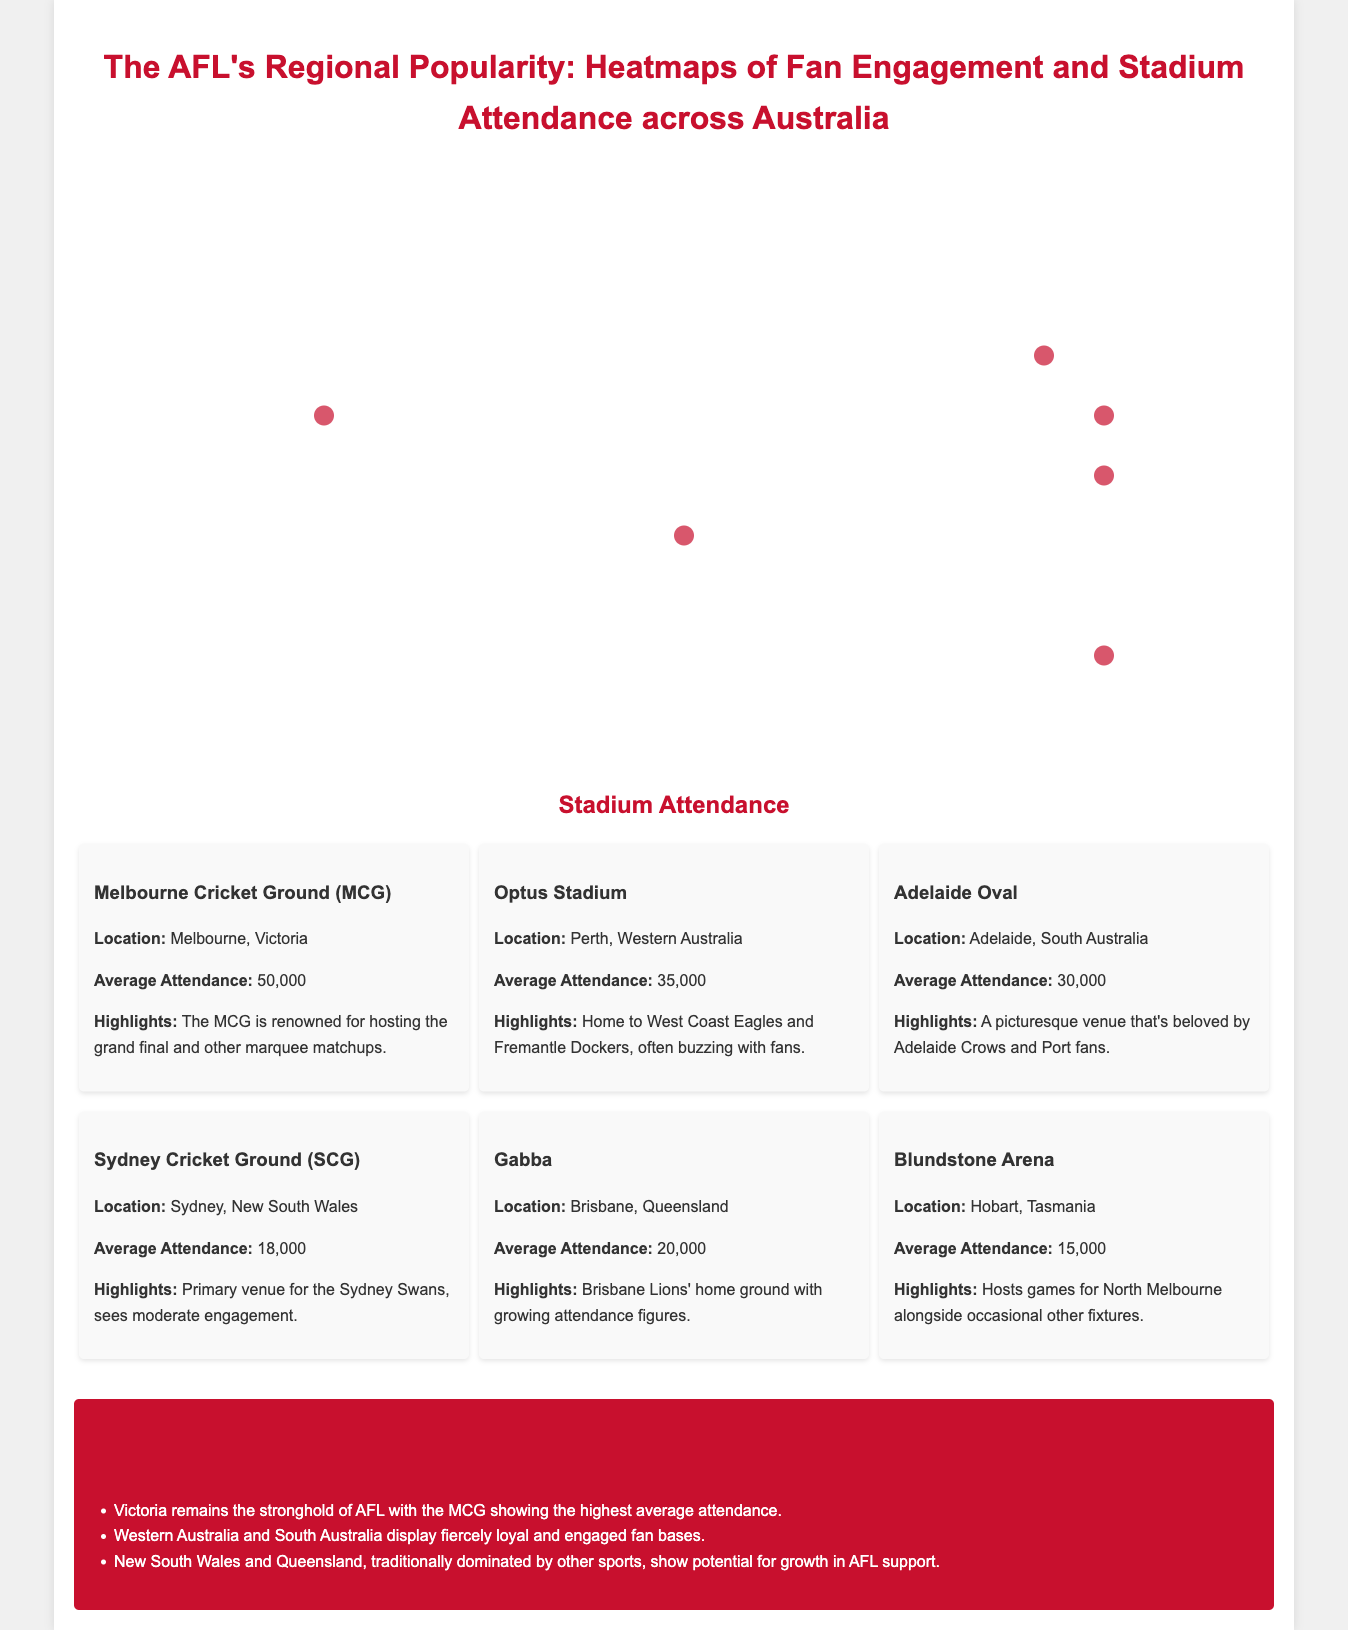What is the average attendance at the Melbourne Cricket Ground? The average attendance at the MCG is stated as 50,000 in the document.
Answer: 50,000 Which region has the highest fan engagement according to the infographic? The document highlights that Victoria has the highest fan engagement with clubs like Collingwood and Richmond.
Answer: Victoria What is the home ground for the Brisbane Lions? The document mentions the Gabba as the home ground for the Brisbane Lions.
Answer: Gabba Which stadium has the highest average attendance among the listed stadiums? The document specifies that the Melbourne Cricket Ground (MCG) has the highest average attendance.
Answer: Melbourne Cricket Ground (MCG) How does the average attendance of the Sydney Cricket Ground compare to that of Adelaide Oval? The average attendance for the SCG is 18,000, while the Adelaide Oval has an average attendance of 30,000. This suggests that the Adelaide Oval has higher attendance.
Answer: Adelaide Oval has higher attendance What does the infographic suggest about the potential for AFL growth in New South Wales? The insights in the document indicate that New South Wales has lower overall AFL engagement but shows potential for growth.
Answer: Potential for growth Which two teams are mentioned as driving fan engagement in Western Australia? According to the document, the West Coast Eagles and Fremantle Dockers drive fan engagement in Western Australia.
Answer: West Coast Eagles and Fremantle Dockers What is a unique characteristic of AFL fan engagement in Tasmania? The document notes that Tasmania doesn’t have its own AFL team, yet there’s strong fan engagement with clubs like Hawthorn.
Answer: Strong fan engagement without a local team 